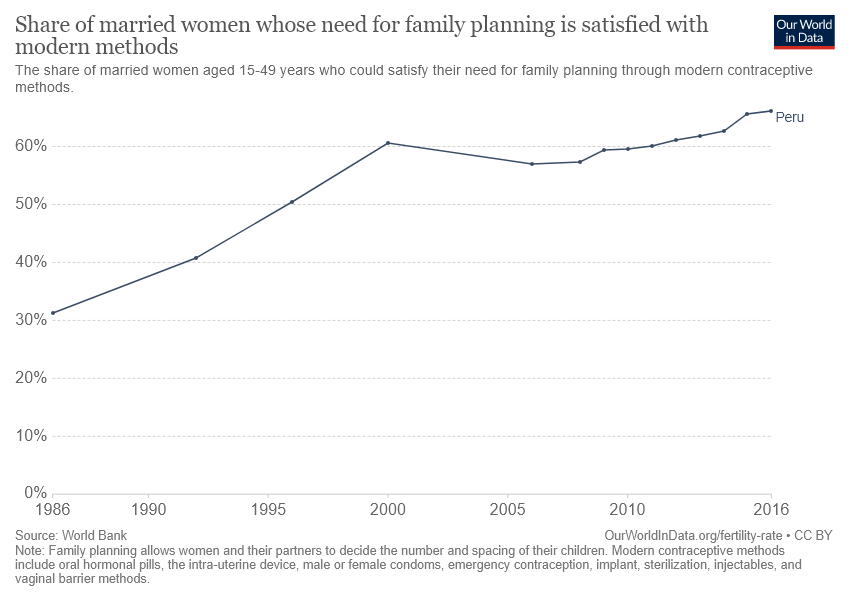Identify some key points in this picture. What is the difference in value between the years 1995 and 2000? In 1995, the value was 10, and in 2000, the value was also 10. In 2016, it represented Peru. 